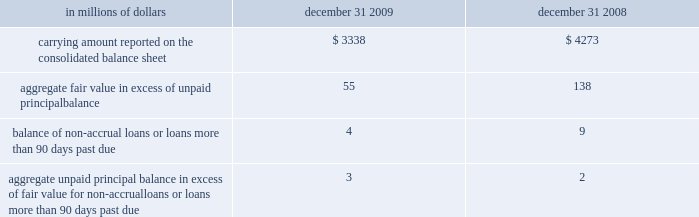Certain mortgage loans citigroup has elected the fair value option for certain purchased and originated prime fixed-rate and conforming adjustable-rate first mortgage loans held-for-sale .
These loans are intended for sale or securitization and are hedged with derivative instruments .
The company has elected the fair value option to mitigate accounting mismatches in cases where hedge .
The changes in fair values of these mortgage loans are reported in other revenue in the company 2019s consolidated statement of income .
The changes in fair value during the years ended december 31 , 2009 and 2008 due to instrument-specific credit risk resulted in a $ 10 million loss and $ 32 million loss , respectively .
Related interest income continues to be measured based on the contractual interest rates and reported as such in the consolidated statement of income .
Mortgage servicing rights the company accounts for mortgage servicing rights ( msrs ) at fair value .
Fair value for msrs is determined using an option-adjusted spread valuation approach .
This approach consists of projecting servicing cash flows under multiple interest-rate scenarios and discounting these cash flows using risk-adjusted rates .
The model assumptions used in the valuation of msrs include mortgage prepayment speeds and discount rates .
The fair value of msrs is primarily affected by changes in prepayments that result from shifts in mortgage interest rates .
In managing this risk , the company hedges a significant portion of the values of its msrs through the use of interest-rate derivative contracts , forward-purchase commitments of mortgage-backed securities , and purchased securities classified as trading .
See note 23 to the consolidated financial statements for further discussions regarding the accounting and reporting of msrs .
These msrs , which totaled $ 6.5 billion and $ 5.7 billion as of december 31 , 2009 and 2008 , respectively , are classified as mortgage servicing rights on citigroup 2019s consolidated balance sheet .
Changes in fair value of msrs are recorded in commissions and fees in the company 2019s consolidated statement of income .
Certain structured liabilities the company has elected the fair value option for certain structured liabilities whose performance is linked to structured interest rates , inflation or currency risks ( 201cstructured liabilities 201d ) .
The company elected the fair value option , because these exposures are considered to be trading-related positions and , therefore , are managed on a fair value basis .
These positions will continue to be classified as debt , deposits or derivatives ( trading account liabilities ) on the company 2019s consolidated balance sheet according to their legal form .
For those structured liabilities classified as long-term debt for which the fair value option has been elected , the aggregate unpaid principal balance exceeded the aggregate fair value by $ 125 million and $ 671 million as of december 31 , 2009 and 2008 , respectively .
The change in fair value for these structured liabilities is reported in principal transactions in the company 2019s consolidated statement of income .
Related interest expense is measured based on the contractual interest rates and reported as such in the consolidated income statement .
Certain non-structured liabilities the company has elected the fair value option for certain non-structured liabilities with fixed and floating interest rates ( 201cnon-structured liabilities 201d ) .
The company has elected the fair value option where the interest-rate risk of such liabilities is economically hedged with derivative contracts or the proceeds are used to purchase financial assets that will also be accounted for at fair value through earnings .
The election has been made to mitigate accounting mismatches and to achieve operational simplifications .
These positions are reported in short-term borrowings and long-term debt on the company 2019s consolidated balance sheet .
For those non-structured liabilities classified as short-term borrowings for which the fair value option has been elected , the aggregate unpaid principal balance exceeded the aggregate fair value of such instruments by $ 220 million as of december 31 , 2008 .
For non-structured liabilities classified as long-term debt for which the fair value option has been elected , the aggregate unpaid principal balance exceeded the aggregate fair value by $ 1542 million and $ 856 million as of december 31 , 2009 and 2008 , respectively .
The change in fair value for these non-structured liabilities is reported in principal transactions in the company 2019s consolidated statement of income .
Related interest expense continues to be measured based on the contractual interest rates and reported as such in the consolidated income statement .
Accounting is complex and to achieve operational simplifications .
The fair value option was not elected for loans held-for-investment , as those loans are not hedged with derivative instruments .
The following table provides information about certain mortgage loans carried at fair value: .
What was the change in carrying amount reported on the consolidated balance sheet in millions from 2008 to 2009? 
Computations: (3338 - 4273)
Answer: -935.0. Certain mortgage loans citigroup has elected the fair value option for certain purchased and originated prime fixed-rate and conforming adjustable-rate first mortgage loans held-for-sale .
These loans are intended for sale or securitization and are hedged with derivative instruments .
The company has elected the fair value option to mitigate accounting mismatches in cases where hedge .
The changes in fair values of these mortgage loans are reported in other revenue in the company 2019s consolidated statement of income .
The changes in fair value during the years ended december 31 , 2009 and 2008 due to instrument-specific credit risk resulted in a $ 10 million loss and $ 32 million loss , respectively .
Related interest income continues to be measured based on the contractual interest rates and reported as such in the consolidated statement of income .
Mortgage servicing rights the company accounts for mortgage servicing rights ( msrs ) at fair value .
Fair value for msrs is determined using an option-adjusted spread valuation approach .
This approach consists of projecting servicing cash flows under multiple interest-rate scenarios and discounting these cash flows using risk-adjusted rates .
The model assumptions used in the valuation of msrs include mortgage prepayment speeds and discount rates .
The fair value of msrs is primarily affected by changes in prepayments that result from shifts in mortgage interest rates .
In managing this risk , the company hedges a significant portion of the values of its msrs through the use of interest-rate derivative contracts , forward-purchase commitments of mortgage-backed securities , and purchased securities classified as trading .
See note 23 to the consolidated financial statements for further discussions regarding the accounting and reporting of msrs .
These msrs , which totaled $ 6.5 billion and $ 5.7 billion as of december 31 , 2009 and 2008 , respectively , are classified as mortgage servicing rights on citigroup 2019s consolidated balance sheet .
Changes in fair value of msrs are recorded in commissions and fees in the company 2019s consolidated statement of income .
Certain structured liabilities the company has elected the fair value option for certain structured liabilities whose performance is linked to structured interest rates , inflation or currency risks ( 201cstructured liabilities 201d ) .
The company elected the fair value option , because these exposures are considered to be trading-related positions and , therefore , are managed on a fair value basis .
These positions will continue to be classified as debt , deposits or derivatives ( trading account liabilities ) on the company 2019s consolidated balance sheet according to their legal form .
For those structured liabilities classified as long-term debt for which the fair value option has been elected , the aggregate unpaid principal balance exceeded the aggregate fair value by $ 125 million and $ 671 million as of december 31 , 2009 and 2008 , respectively .
The change in fair value for these structured liabilities is reported in principal transactions in the company 2019s consolidated statement of income .
Related interest expense is measured based on the contractual interest rates and reported as such in the consolidated income statement .
Certain non-structured liabilities the company has elected the fair value option for certain non-structured liabilities with fixed and floating interest rates ( 201cnon-structured liabilities 201d ) .
The company has elected the fair value option where the interest-rate risk of such liabilities is economically hedged with derivative contracts or the proceeds are used to purchase financial assets that will also be accounted for at fair value through earnings .
The election has been made to mitigate accounting mismatches and to achieve operational simplifications .
These positions are reported in short-term borrowings and long-term debt on the company 2019s consolidated balance sheet .
For those non-structured liabilities classified as short-term borrowings for which the fair value option has been elected , the aggregate unpaid principal balance exceeded the aggregate fair value of such instruments by $ 220 million as of december 31 , 2008 .
For non-structured liabilities classified as long-term debt for which the fair value option has been elected , the aggregate unpaid principal balance exceeded the aggregate fair value by $ 1542 million and $ 856 million as of december 31 , 2009 and 2008 , respectively .
The change in fair value for these non-structured liabilities is reported in principal transactions in the company 2019s consolidated statement of income .
Related interest expense continues to be measured based on the contractual interest rates and reported as such in the consolidated income statement .
Accounting is complex and to achieve operational simplifications .
The fair value option was not elected for loans held-for-investment , as those loans are not hedged with derivative instruments .
The following table provides information about certain mortgage loans carried at fair value: .
What was the percentage change in carrying amount reported on the consolidated balance sheet from 2008 to 2009? 
Computations: ((3338 - 4273) / 4273)
Answer: -0.21882. Certain mortgage loans citigroup has elected the fair value option for certain purchased and originated prime fixed-rate and conforming adjustable-rate first mortgage loans held-for-sale .
These loans are intended for sale or securitization and are hedged with derivative instruments .
The company has elected the fair value option to mitigate accounting mismatches in cases where hedge .
The changes in fair values of these mortgage loans are reported in other revenue in the company 2019s consolidated statement of income .
The changes in fair value during the years ended december 31 , 2009 and 2008 due to instrument-specific credit risk resulted in a $ 10 million loss and $ 32 million loss , respectively .
Related interest income continues to be measured based on the contractual interest rates and reported as such in the consolidated statement of income .
Mortgage servicing rights the company accounts for mortgage servicing rights ( msrs ) at fair value .
Fair value for msrs is determined using an option-adjusted spread valuation approach .
This approach consists of projecting servicing cash flows under multiple interest-rate scenarios and discounting these cash flows using risk-adjusted rates .
The model assumptions used in the valuation of msrs include mortgage prepayment speeds and discount rates .
The fair value of msrs is primarily affected by changes in prepayments that result from shifts in mortgage interest rates .
In managing this risk , the company hedges a significant portion of the values of its msrs through the use of interest-rate derivative contracts , forward-purchase commitments of mortgage-backed securities , and purchased securities classified as trading .
See note 23 to the consolidated financial statements for further discussions regarding the accounting and reporting of msrs .
These msrs , which totaled $ 6.5 billion and $ 5.7 billion as of december 31 , 2009 and 2008 , respectively , are classified as mortgage servicing rights on citigroup 2019s consolidated balance sheet .
Changes in fair value of msrs are recorded in commissions and fees in the company 2019s consolidated statement of income .
Certain structured liabilities the company has elected the fair value option for certain structured liabilities whose performance is linked to structured interest rates , inflation or currency risks ( 201cstructured liabilities 201d ) .
The company elected the fair value option , because these exposures are considered to be trading-related positions and , therefore , are managed on a fair value basis .
These positions will continue to be classified as debt , deposits or derivatives ( trading account liabilities ) on the company 2019s consolidated balance sheet according to their legal form .
For those structured liabilities classified as long-term debt for which the fair value option has been elected , the aggregate unpaid principal balance exceeded the aggregate fair value by $ 125 million and $ 671 million as of december 31 , 2009 and 2008 , respectively .
The change in fair value for these structured liabilities is reported in principal transactions in the company 2019s consolidated statement of income .
Related interest expense is measured based on the contractual interest rates and reported as such in the consolidated income statement .
Certain non-structured liabilities the company has elected the fair value option for certain non-structured liabilities with fixed and floating interest rates ( 201cnon-structured liabilities 201d ) .
The company has elected the fair value option where the interest-rate risk of such liabilities is economically hedged with derivative contracts or the proceeds are used to purchase financial assets that will also be accounted for at fair value through earnings .
The election has been made to mitigate accounting mismatches and to achieve operational simplifications .
These positions are reported in short-term borrowings and long-term debt on the company 2019s consolidated balance sheet .
For those non-structured liabilities classified as short-term borrowings for which the fair value option has been elected , the aggregate unpaid principal balance exceeded the aggregate fair value of such instruments by $ 220 million as of december 31 , 2008 .
For non-structured liabilities classified as long-term debt for which the fair value option has been elected , the aggregate unpaid principal balance exceeded the aggregate fair value by $ 1542 million and $ 856 million as of december 31 , 2009 and 2008 , respectively .
The change in fair value for these non-structured liabilities is reported in principal transactions in the company 2019s consolidated statement of income .
Related interest expense continues to be measured based on the contractual interest rates and reported as such in the consolidated income statement .
Accounting is complex and to achieve operational simplifications .
The fair value option was not elected for loans held-for-investment , as those loans are not hedged with derivative instruments .
The following table provides information about certain mortgage loans carried at fair value: .
What was the percent of the 2008 to 2009 unpaid principal balance exceeded the aggregate fair value non-structured liabilities classified as long-term debt for which the fair value option has been elected? 
Computations: (856 / 1542)
Answer: 0.55512. 